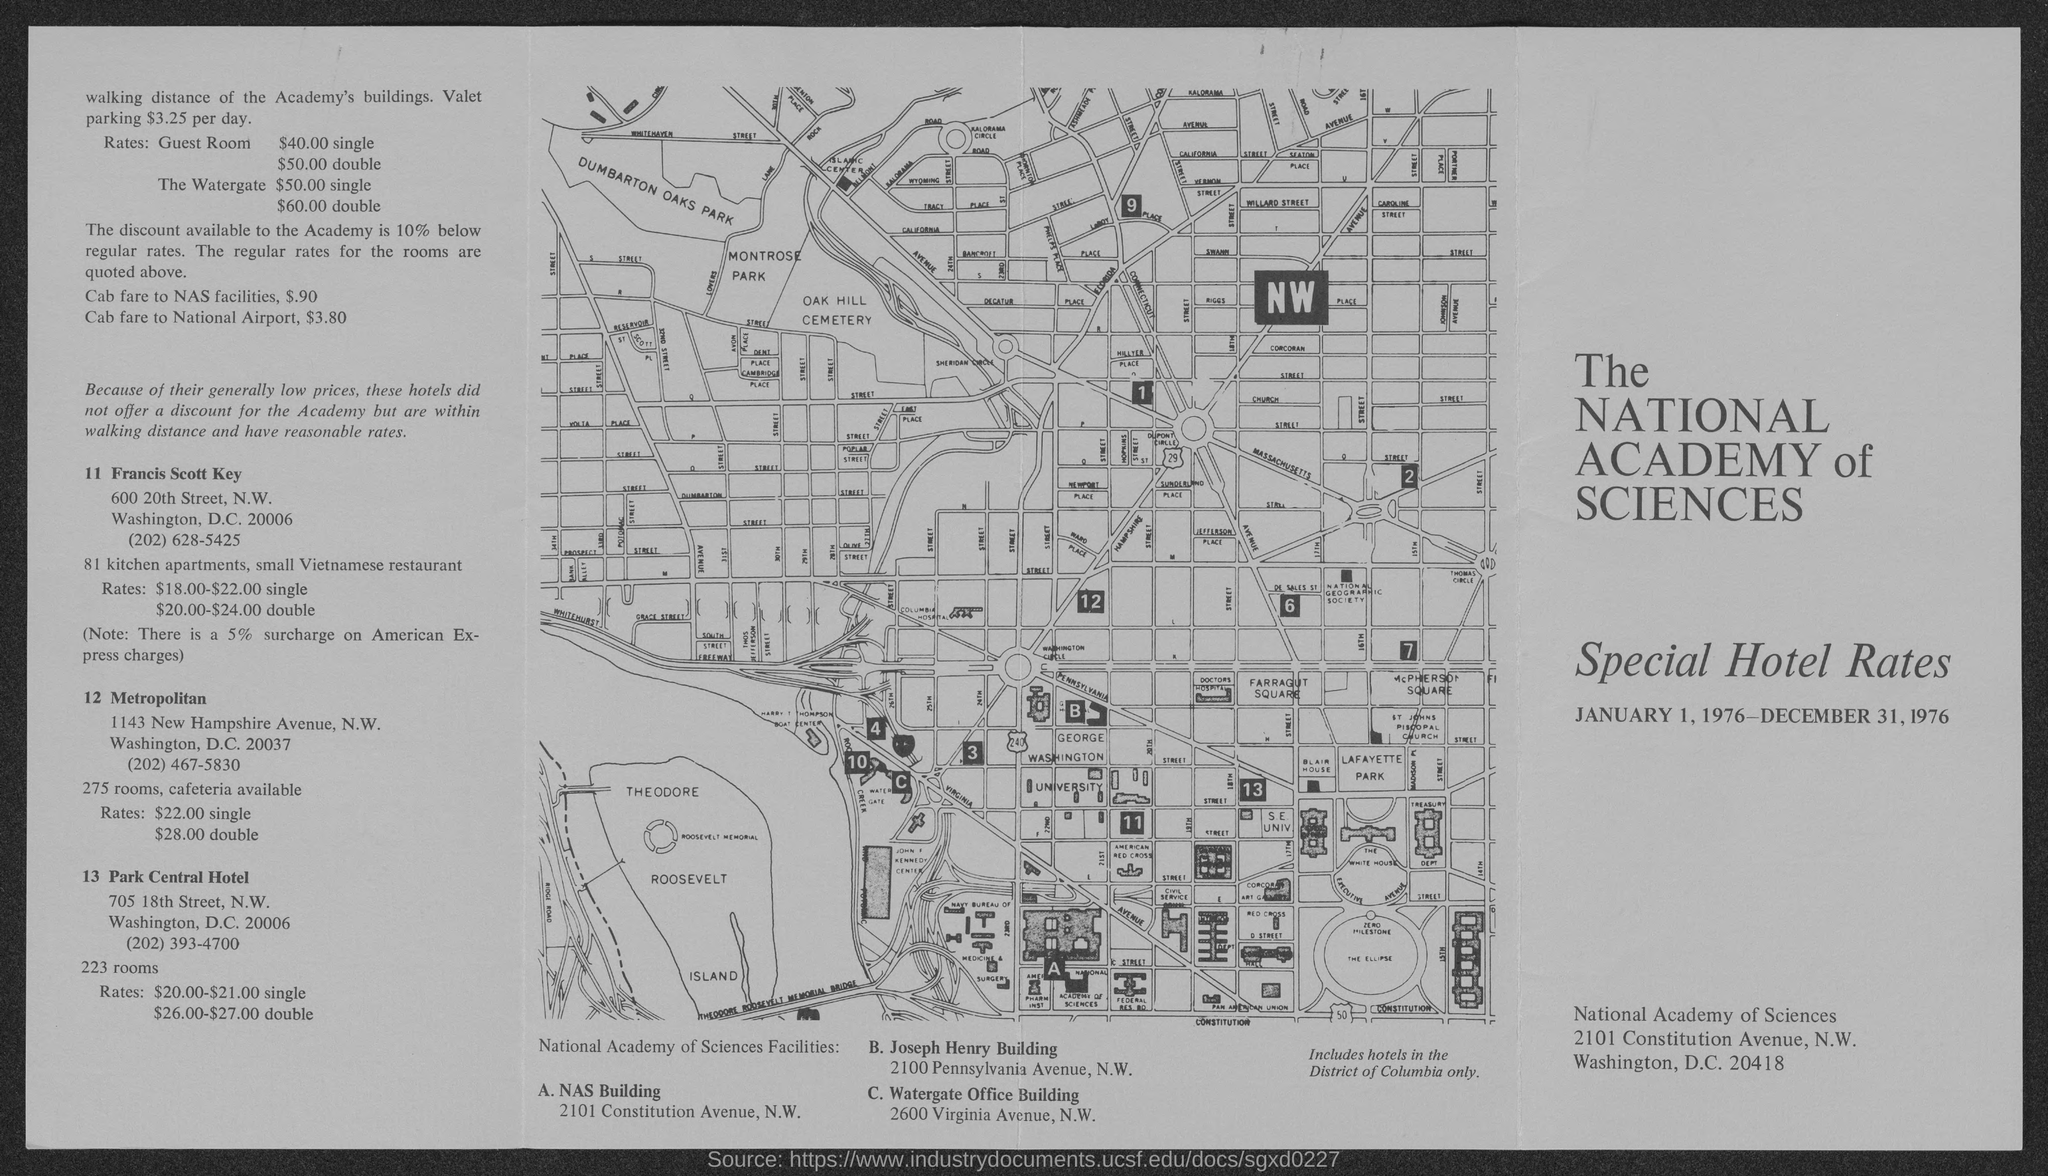List a handful of essential elements in this visual. The water gate rate for doubles is $60.00. The estimated cost of the taxi fare to NAS Facilities is $0.90. The discount available to the Academy is 10% below regular rates. The rate for a single guest room is $40.00. The cab fare to National Airport is $3.80. 